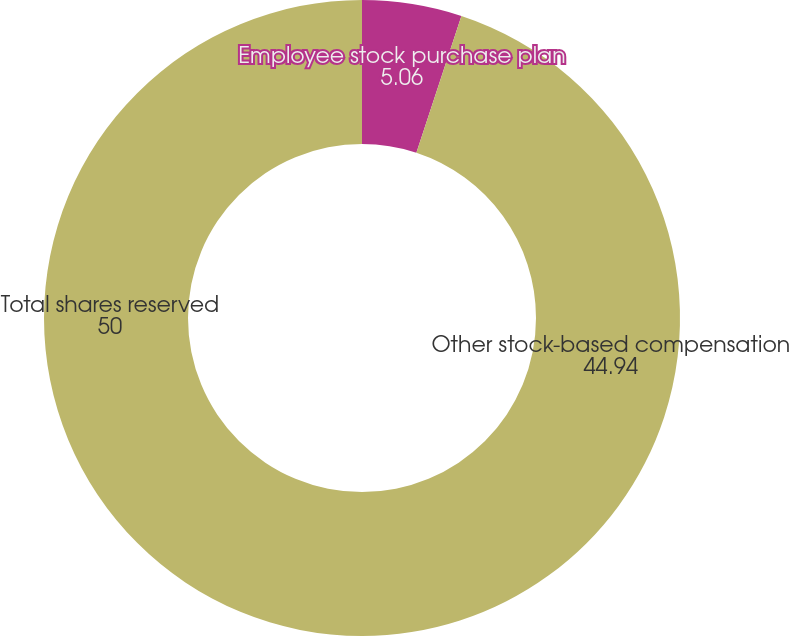Convert chart to OTSL. <chart><loc_0><loc_0><loc_500><loc_500><pie_chart><fcel>Employee stock purchase plan<fcel>Other stock-based compensation<fcel>Total shares reserved<nl><fcel>5.06%<fcel>44.94%<fcel>50.0%<nl></chart> 